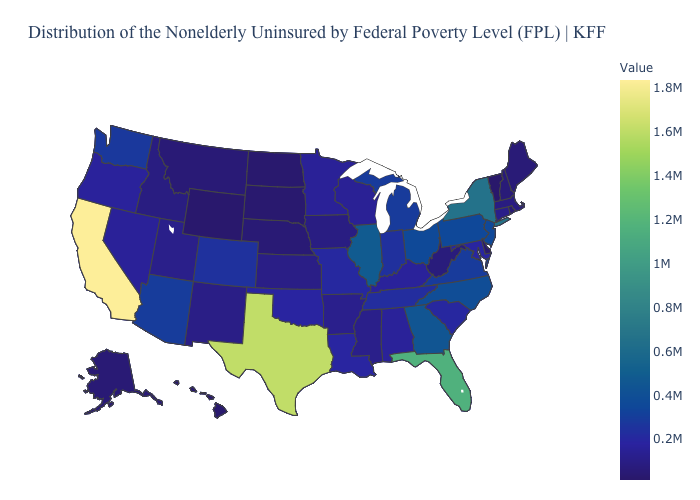Among the states that border Delaware , which have the lowest value?
Give a very brief answer. Maryland. Does Colorado have the lowest value in the USA?
Quick response, please. No. Does the map have missing data?
Write a very short answer. No. Among the states that border Connecticut , does Rhode Island have the highest value?
Quick response, please. No. Does the map have missing data?
Be succinct. No. Which states hav the highest value in the West?
Answer briefly. California. Among the states that border Kansas , which have the lowest value?
Give a very brief answer. Nebraska. 